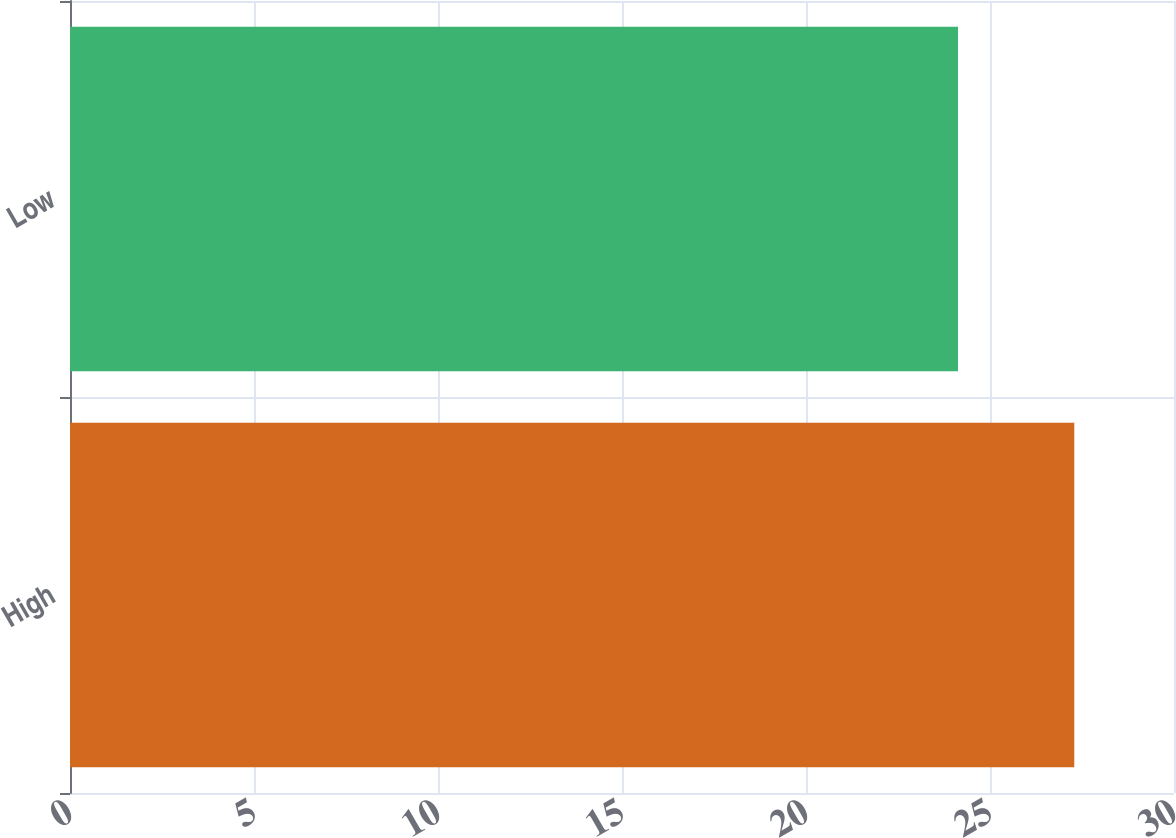<chart> <loc_0><loc_0><loc_500><loc_500><bar_chart><fcel>High<fcel>Low<nl><fcel>27.29<fcel>24.13<nl></chart> 